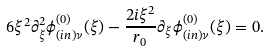<formula> <loc_0><loc_0><loc_500><loc_500>6 \xi ^ { 2 } \partial ^ { 2 } _ { \xi } \phi ^ { ( 0 ) } _ { ( i n ) \nu } ( \xi ) - \frac { 2 i \xi ^ { 2 } } { r _ { 0 } } \partial _ { \xi } \phi ^ { ( 0 ) } _ { ( i n ) \nu } ( \xi ) = 0 .</formula> 